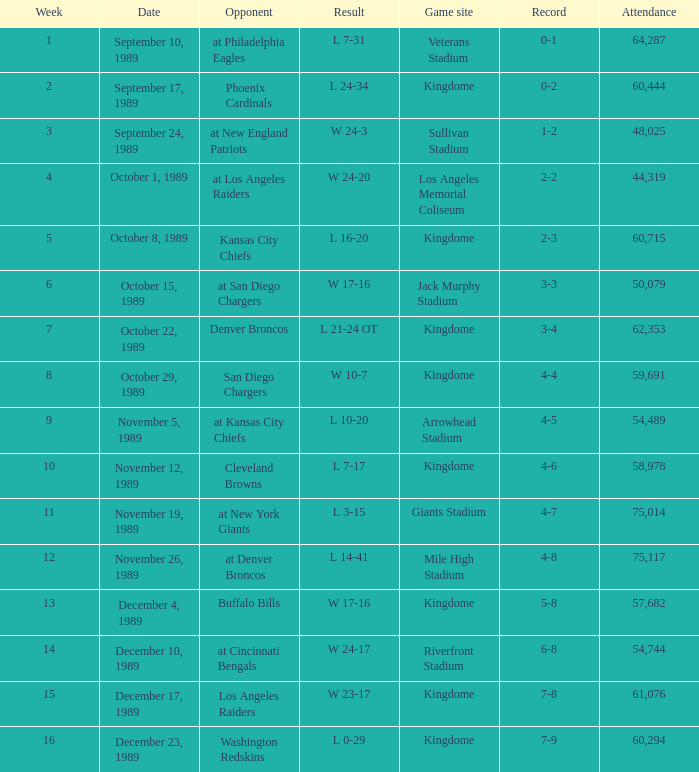Specify the consequence for the realm game venue and rival of denver broncos. L 21-24 OT. 